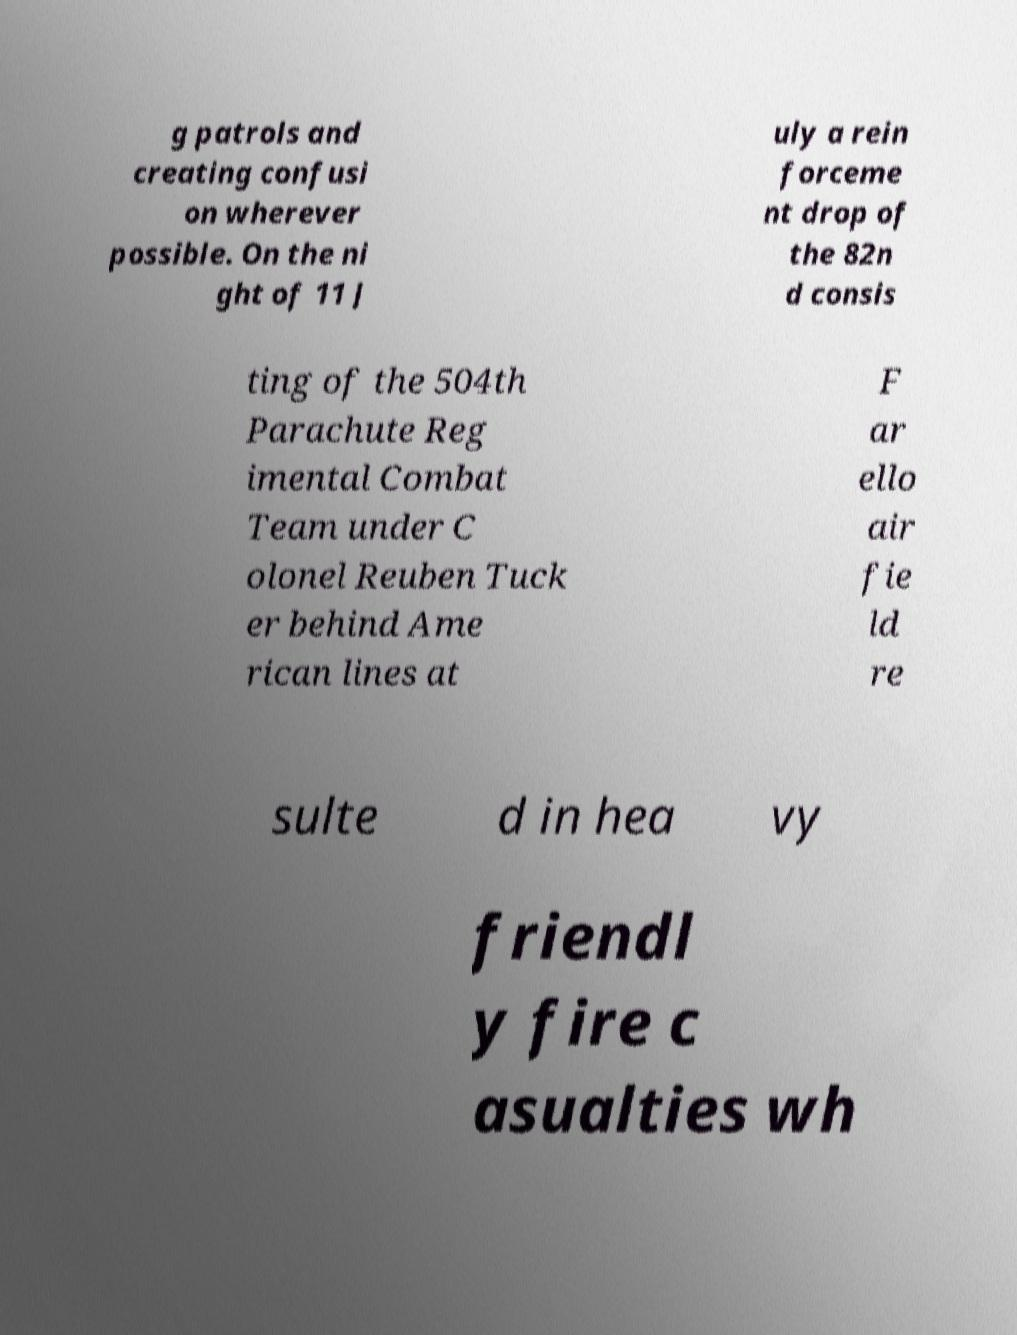Can you accurately transcribe the text from the provided image for me? g patrols and creating confusi on wherever possible. On the ni ght of 11 J uly a rein forceme nt drop of the 82n d consis ting of the 504th Parachute Reg imental Combat Team under C olonel Reuben Tuck er behind Ame rican lines at F ar ello air fie ld re sulte d in hea vy friendl y fire c asualties wh 